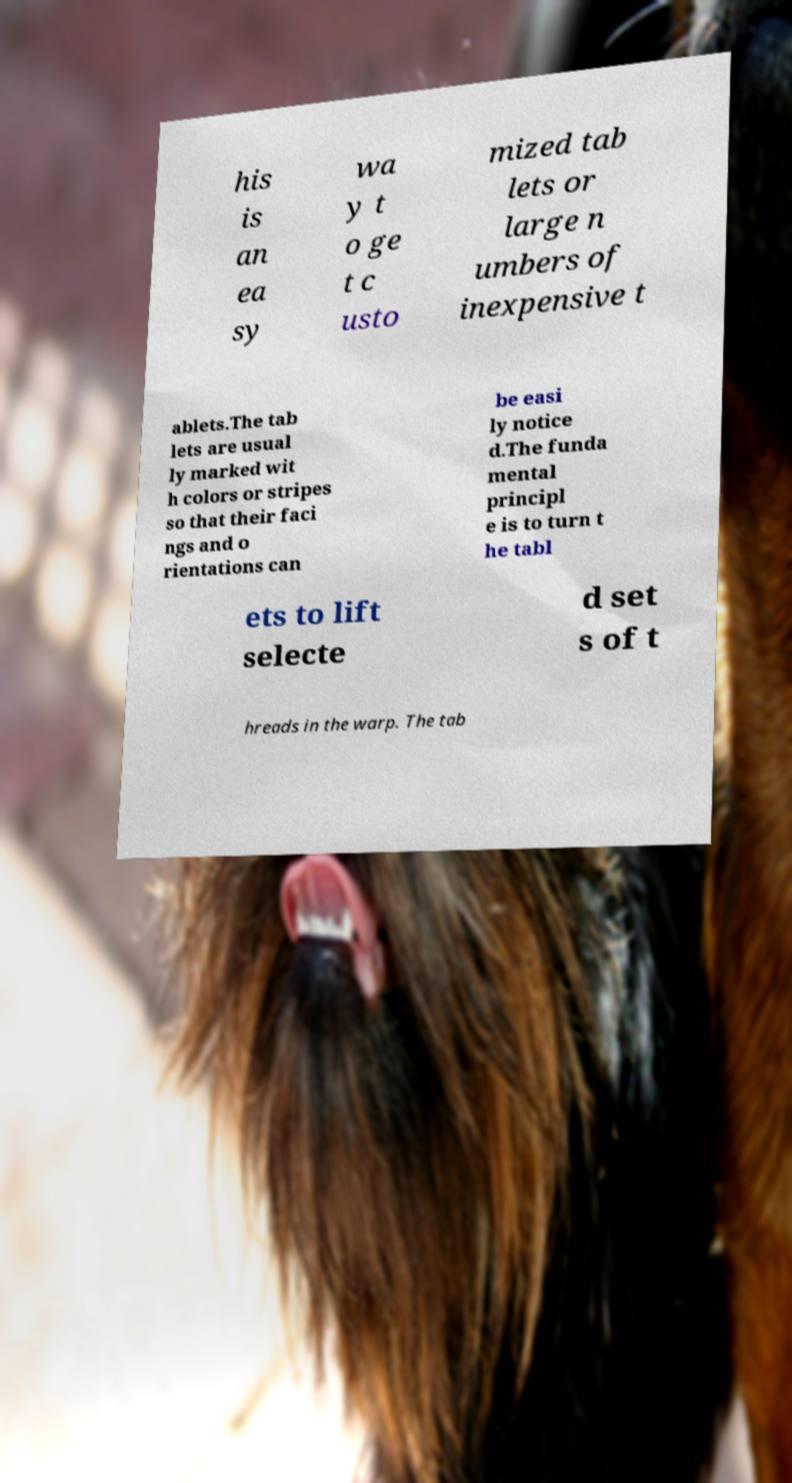Can you read and provide the text displayed in the image?This photo seems to have some interesting text. Can you extract and type it out for me? his is an ea sy wa y t o ge t c usto mized tab lets or large n umbers of inexpensive t ablets.The tab lets are usual ly marked wit h colors or stripes so that their faci ngs and o rientations can be easi ly notice d.The funda mental principl e is to turn t he tabl ets to lift selecte d set s of t hreads in the warp. The tab 